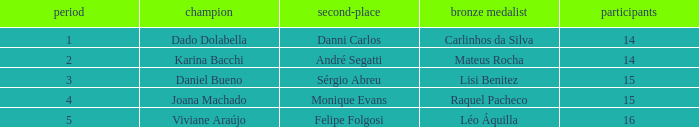In what season did Raquel Pacheco finish in third place? 4.0. 